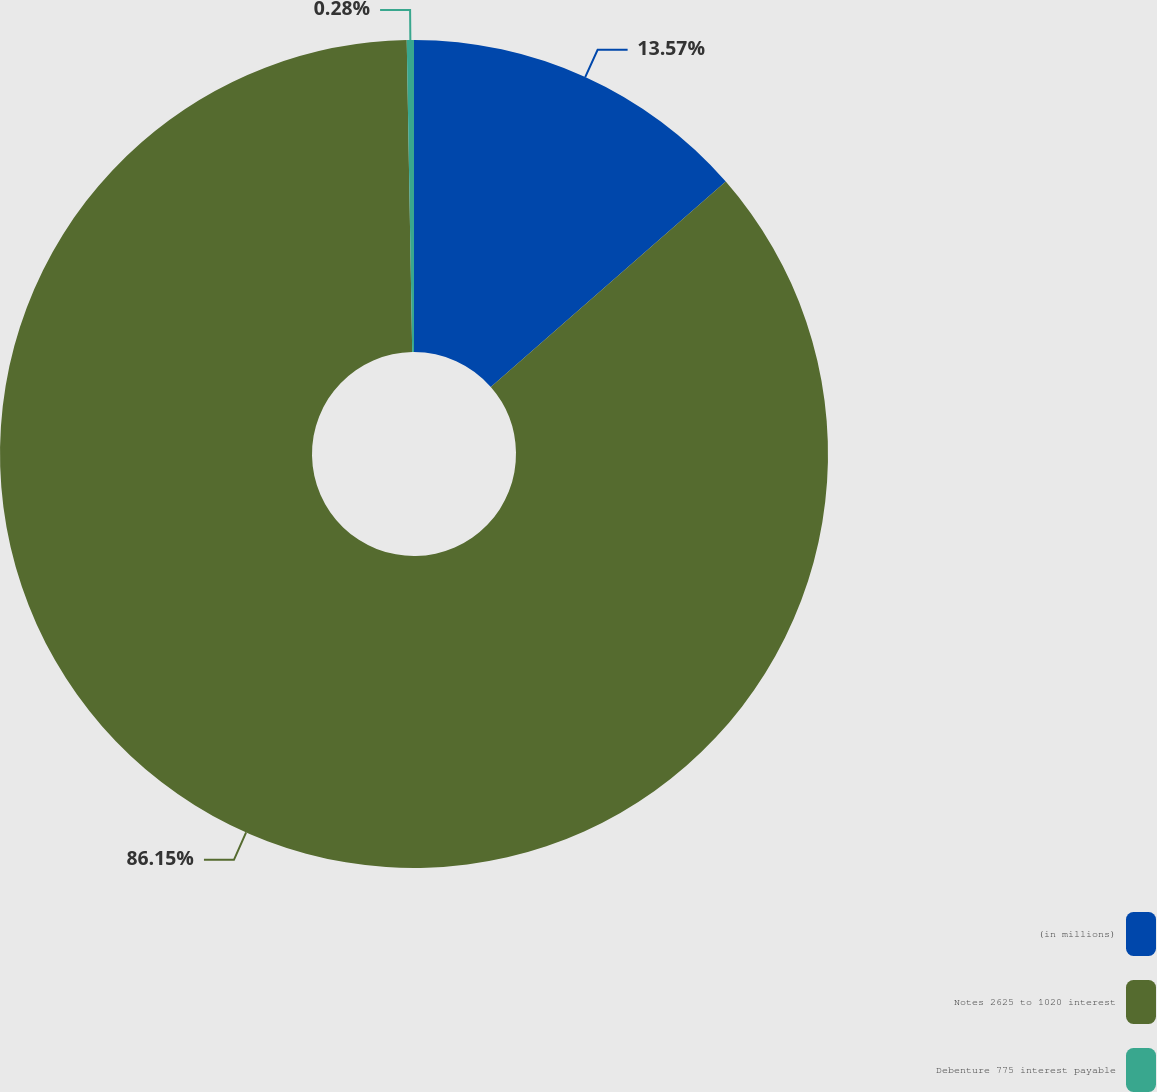Convert chart. <chart><loc_0><loc_0><loc_500><loc_500><pie_chart><fcel>(in millions)<fcel>Notes 2625 to 1020 interest<fcel>Debenture 775 interest payable<nl><fcel>13.57%<fcel>86.14%<fcel>0.28%<nl></chart> 